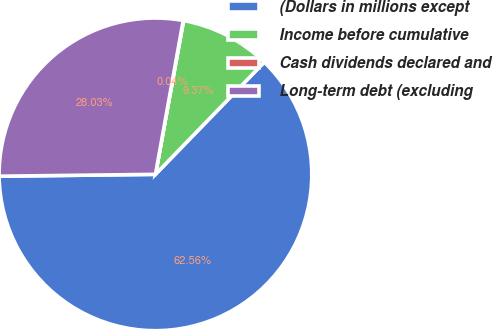Convert chart. <chart><loc_0><loc_0><loc_500><loc_500><pie_chart><fcel>(Dollars in millions except<fcel>Income before cumulative<fcel>Cash dividends declared and<fcel>Long-term debt (excluding<nl><fcel>62.55%<fcel>9.37%<fcel>0.04%<fcel>28.03%<nl></chart> 